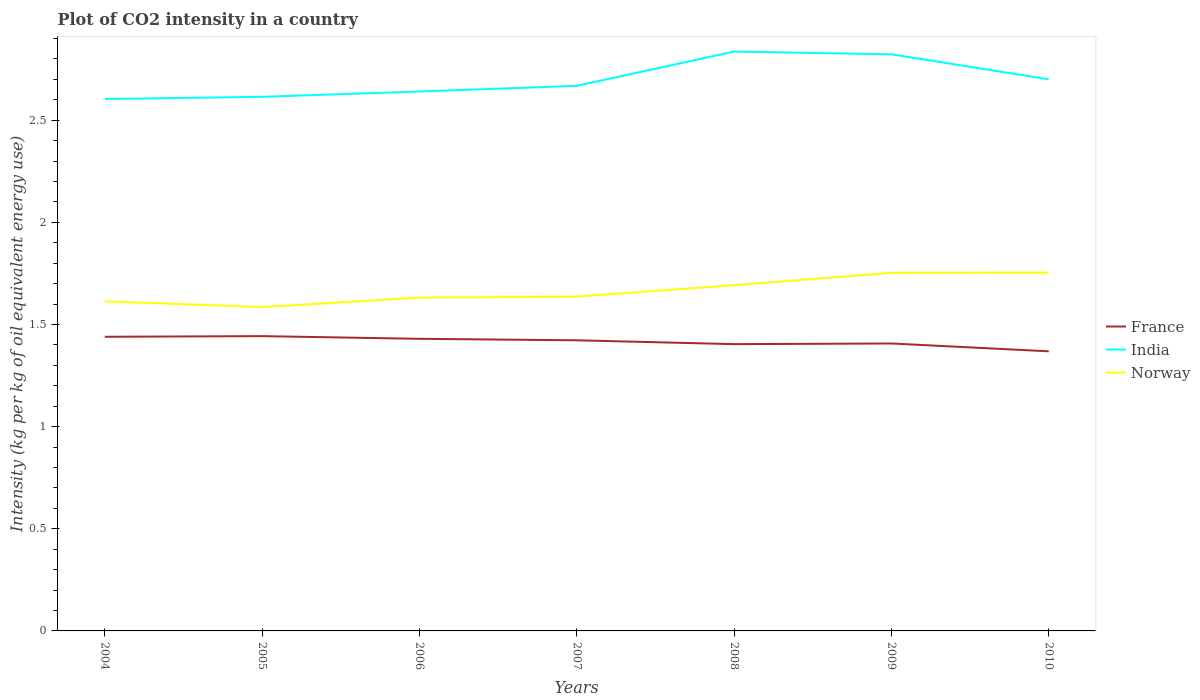How many different coloured lines are there?
Offer a terse response. 3. Does the line corresponding to India intersect with the line corresponding to Norway?
Provide a succinct answer. No. Is the number of lines equal to the number of legend labels?
Ensure brevity in your answer.  Yes. Across all years, what is the maximum CO2 intensity in in Norway?
Your response must be concise. 1.59. In which year was the CO2 intensity in in India maximum?
Make the answer very short. 2004. What is the total CO2 intensity in in Norway in the graph?
Keep it short and to the point. -0.14. What is the difference between the highest and the second highest CO2 intensity in in India?
Your response must be concise. 0.23. What is the difference between the highest and the lowest CO2 intensity in in Norway?
Your answer should be compact. 3. Is the CO2 intensity in in India strictly greater than the CO2 intensity in in France over the years?
Offer a very short reply. No. How many years are there in the graph?
Provide a succinct answer. 7. Are the values on the major ticks of Y-axis written in scientific E-notation?
Your response must be concise. No. Where does the legend appear in the graph?
Your response must be concise. Center right. How many legend labels are there?
Offer a very short reply. 3. How are the legend labels stacked?
Provide a short and direct response. Vertical. What is the title of the graph?
Provide a short and direct response. Plot of CO2 intensity in a country. What is the label or title of the Y-axis?
Your response must be concise. Intensity (kg per kg of oil equivalent energy use). What is the Intensity (kg per kg of oil equivalent energy use) of France in 2004?
Offer a terse response. 1.44. What is the Intensity (kg per kg of oil equivalent energy use) in India in 2004?
Give a very brief answer. 2.6. What is the Intensity (kg per kg of oil equivalent energy use) in Norway in 2004?
Make the answer very short. 1.61. What is the Intensity (kg per kg of oil equivalent energy use) in France in 2005?
Your answer should be very brief. 1.44. What is the Intensity (kg per kg of oil equivalent energy use) of India in 2005?
Ensure brevity in your answer.  2.61. What is the Intensity (kg per kg of oil equivalent energy use) in Norway in 2005?
Ensure brevity in your answer.  1.59. What is the Intensity (kg per kg of oil equivalent energy use) of France in 2006?
Your answer should be very brief. 1.43. What is the Intensity (kg per kg of oil equivalent energy use) of India in 2006?
Your answer should be compact. 2.64. What is the Intensity (kg per kg of oil equivalent energy use) of Norway in 2006?
Your answer should be very brief. 1.63. What is the Intensity (kg per kg of oil equivalent energy use) in France in 2007?
Your answer should be very brief. 1.42. What is the Intensity (kg per kg of oil equivalent energy use) of India in 2007?
Your response must be concise. 2.67. What is the Intensity (kg per kg of oil equivalent energy use) in Norway in 2007?
Provide a short and direct response. 1.64. What is the Intensity (kg per kg of oil equivalent energy use) of France in 2008?
Keep it short and to the point. 1.4. What is the Intensity (kg per kg of oil equivalent energy use) in India in 2008?
Your response must be concise. 2.84. What is the Intensity (kg per kg of oil equivalent energy use) in Norway in 2008?
Your answer should be very brief. 1.69. What is the Intensity (kg per kg of oil equivalent energy use) of France in 2009?
Provide a succinct answer. 1.41. What is the Intensity (kg per kg of oil equivalent energy use) in India in 2009?
Keep it short and to the point. 2.82. What is the Intensity (kg per kg of oil equivalent energy use) in Norway in 2009?
Offer a very short reply. 1.75. What is the Intensity (kg per kg of oil equivalent energy use) in France in 2010?
Offer a terse response. 1.37. What is the Intensity (kg per kg of oil equivalent energy use) of India in 2010?
Your answer should be very brief. 2.7. What is the Intensity (kg per kg of oil equivalent energy use) in Norway in 2010?
Your answer should be compact. 1.75. Across all years, what is the maximum Intensity (kg per kg of oil equivalent energy use) of France?
Give a very brief answer. 1.44. Across all years, what is the maximum Intensity (kg per kg of oil equivalent energy use) in India?
Provide a succinct answer. 2.84. Across all years, what is the maximum Intensity (kg per kg of oil equivalent energy use) in Norway?
Ensure brevity in your answer.  1.75. Across all years, what is the minimum Intensity (kg per kg of oil equivalent energy use) in France?
Offer a very short reply. 1.37. Across all years, what is the minimum Intensity (kg per kg of oil equivalent energy use) of India?
Keep it short and to the point. 2.6. Across all years, what is the minimum Intensity (kg per kg of oil equivalent energy use) of Norway?
Provide a succinct answer. 1.59. What is the total Intensity (kg per kg of oil equivalent energy use) of France in the graph?
Your response must be concise. 9.91. What is the total Intensity (kg per kg of oil equivalent energy use) in India in the graph?
Provide a succinct answer. 18.89. What is the total Intensity (kg per kg of oil equivalent energy use) in Norway in the graph?
Offer a terse response. 11.67. What is the difference between the Intensity (kg per kg of oil equivalent energy use) in France in 2004 and that in 2005?
Your answer should be very brief. -0. What is the difference between the Intensity (kg per kg of oil equivalent energy use) of India in 2004 and that in 2005?
Your answer should be compact. -0.01. What is the difference between the Intensity (kg per kg of oil equivalent energy use) of Norway in 2004 and that in 2005?
Offer a terse response. 0.03. What is the difference between the Intensity (kg per kg of oil equivalent energy use) in France in 2004 and that in 2006?
Your answer should be very brief. 0.01. What is the difference between the Intensity (kg per kg of oil equivalent energy use) in India in 2004 and that in 2006?
Provide a succinct answer. -0.04. What is the difference between the Intensity (kg per kg of oil equivalent energy use) in Norway in 2004 and that in 2006?
Offer a very short reply. -0.02. What is the difference between the Intensity (kg per kg of oil equivalent energy use) of France in 2004 and that in 2007?
Provide a short and direct response. 0.02. What is the difference between the Intensity (kg per kg of oil equivalent energy use) of India in 2004 and that in 2007?
Provide a short and direct response. -0.06. What is the difference between the Intensity (kg per kg of oil equivalent energy use) of Norway in 2004 and that in 2007?
Keep it short and to the point. -0.02. What is the difference between the Intensity (kg per kg of oil equivalent energy use) of France in 2004 and that in 2008?
Your response must be concise. 0.04. What is the difference between the Intensity (kg per kg of oil equivalent energy use) in India in 2004 and that in 2008?
Provide a short and direct response. -0.23. What is the difference between the Intensity (kg per kg of oil equivalent energy use) of Norway in 2004 and that in 2008?
Offer a terse response. -0.08. What is the difference between the Intensity (kg per kg of oil equivalent energy use) in France in 2004 and that in 2009?
Your response must be concise. 0.03. What is the difference between the Intensity (kg per kg of oil equivalent energy use) of India in 2004 and that in 2009?
Ensure brevity in your answer.  -0.22. What is the difference between the Intensity (kg per kg of oil equivalent energy use) of Norway in 2004 and that in 2009?
Make the answer very short. -0.14. What is the difference between the Intensity (kg per kg of oil equivalent energy use) in France in 2004 and that in 2010?
Ensure brevity in your answer.  0.07. What is the difference between the Intensity (kg per kg of oil equivalent energy use) in India in 2004 and that in 2010?
Offer a terse response. -0.1. What is the difference between the Intensity (kg per kg of oil equivalent energy use) of Norway in 2004 and that in 2010?
Keep it short and to the point. -0.14. What is the difference between the Intensity (kg per kg of oil equivalent energy use) in France in 2005 and that in 2006?
Give a very brief answer. 0.01. What is the difference between the Intensity (kg per kg of oil equivalent energy use) in India in 2005 and that in 2006?
Make the answer very short. -0.03. What is the difference between the Intensity (kg per kg of oil equivalent energy use) in Norway in 2005 and that in 2006?
Give a very brief answer. -0.05. What is the difference between the Intensity (kg per kg of oil equivalent energy use) in France in 2005 and that in 2007?
Keep it short and to the point. 0.02. What is the difference between the Intensity (kg per kg of oil equivalent energy use) in India in 2005 and that in 2007?
Offer a very short reply. -0.05. What is the difference between the Intensity (kg per kg of oil equivalent energy use) in Norway in 2005 and that in 2007?
Give a very brief answer. -0.05. What is the difference between the Intensity (kg per kg of oil equivalent energy use) in France in 2005 and that in 2008?
Your response must be concise. 0.04. What is the difference between the Intensity (kg per kg of oil equivalent energy use) of India in 2005 and that in 2008?
Your answer should be very brief. -0.22. What is the difference between the Intensity (kg per kg of oil equivalent energy use) of Norway in 2005 and that in 2008?
Provide a succinct answer. -0.11. What is the difference between the Intensity (kg per kg of oil equivalent energy use) in France in 2005 and that in 2009?
Your response must be concise. 0.04. What is the difference between the Intensity (kg per kg of oil equivalent energy use) in India in 2005 and that in 2009?
Make the answer very short. -0.21. What is the difference between the Intensity (kg per kg of oil equivalent energy use) of Norway in 2005 and that in 2009?
Provide a short and direct response. -0.17. What is the difference between the Intensity (kg per kg of oil equivalent energy use) in France in 2005 and that in 2010?
Provide a short and direct response. 0.07. What is the difference between the Intensity (kg per kg of oil equivalent energy use) of India in 2005 and that in 2010?
Your answer should be very brief. -0.09. What is the difference between the Intensity (kg per kg of oil equivalent energy use) of Norway in 2005 and that in 2010?
Offer a terse response. -0.17. What is the difference between the Intensity (kg per kg of oil equivalent energy use) of France in 2006 and that in 2007?
Provide a succinct answer. 0.01. What is the difference between the Intensity (kg per kg of oil equivalent energy use) of India in 2006 and that in 2007?
Keep it short and to the point. -0.03. What is the difference between the Intensity (kg per kg of oil equivalent energy use) in Norway in 2006 and that in 2007?
Make the answer very short. -0.01. What is the difference between the Intensity (kg per kg of oil equivalent energy use) of France in 2006 and that in 2008?
Provide a succinct answer. 0.03. What is the difference between the Intensity (kg per kg of oil equivalent energy use) in India in 2006 and that in 2008?
Give a very brief answer. -0.2. What is the difference between the Intensity (kg per kg of oil equivalent energy use) of Norway in 2006 and that in 2008?
Provide a short and direct response. -0.06. What is the difference between the Intensity (kg per kg of oil equivalent energy use) of France in 2006 and that in 2009?
Ensure brevity in your answer.  0.02. What is the difference between the Intensity (kg per kg of oil equivalent energy use) in India in 2006 and that in 2009?
Your response must be concise. -0.18. What is the difference between the Intensity (kg per kg of oil equivalent energy use) of Norway in 2006 and that in 2009?
Your response must be concise. -0.12. What is the difference between the Intensity (kg per kg of oil equivalent energy use) in France in 2006 and that in 2010?
Your answer should be very brief. 0.06. What is the difference between the Intensity (kg per kg of oil equivalent energy use) of India in 2006 and that in 2010?
Ensure brevity in your answer.  -0.06. What is the difference between the Intensity (kg per kg of oil equivalent energy use) of Norway in 2006 and that in 2010?
Your answer should be compact. -0.12. What is the difference between the Intensity (kg per kg of oil equivalent energy use) of France in 2007 and that in 2008?
Keep it short and to the point. 0.02. What is the difference between the Intensity (kg per kg of oil equivalent energy use) of India in 2007 and that in 2008?
Your answer should be compact. -0.17. What is the difference between the Intensity (kg per kg of oil equivalent energy use) in Norway in 2007 and that in 2008?
Provide a short and direct response. -0.06. What is the difference between the Intensity (kg per kg of oil equivalent energy use) of France in 2007 and that in 2009?
Your answer should be compact. 0.02. What is the difference between the Intensity (kg per kg of oil equivalent energy use) of India in 2007 and that in 2009?
Offer a very short reply. -0.15. What is the difference between the Intensity (kg per kg of oil equivalent energy use) in Norway in 2007 and that in 2009?
Offer a terse response. -0.12. What is the difference between the Intensity (kg per kg of oil equivalent energy use) in France in 2007 and that in 2010?
Provide a short and direct response. 0.05. What is the difference between the Intensity (kg per kg of oil equivalent energy use) of India in 2007 and that in 2010?
Keep it short and to the point. -0.03. What is the difference between the Intensity (kg per kg of oil equivalent energy use) of Norway in 2007 and that in 2010?
Your response must be concise. -0.12. What is the difference between the Intensity (kg per kg of oil equivalent energy use) of France in 2008 and that in 2009?
Ensure brevity in your answer.  -0. What is the difference between the Intensity (kg per kg of oil equivalent energy use) of India in 2008 and that in 2009?
Make the answer very short. 0.01. What is the difference between the Intensity (kg per kg of oil equivalent energy use) of Norway in 2008 and that in 2009?
Make the answer very short. -0.06. What is the difference between the Intensity (kg per kg of oil equivalent energy use) in France in 2008 and that in 2010?
Offer a terse response. 0.04. What is the difference between the Intensity (kg per kg of oil equivalent energy use) in India in 2008 and that in 2010?
Your answer should be compact. 0.14. What is the difference between the Intensity (kg per kg of oil equivalent energy use) in Norway in 2008 and that in 2010?
Offer a terse response. -0.06. What is the difference between the Intensity (kg per kg of oil equivalent energy use) of France in 2009 and that in 2010?
Your answer should be very brief. 0.04. What is the difference between the Intensity (kg per kg of oil equivalent energy use) of India in 2009 and that in 2010?
Your answer should be very brief. 0.12. What is the difference between the Intensity (kg per kg of oil equivalent energy use) in Norway in 2009 and that in 2010?
Your response must be concise. -0. What is the difference between the Intensity (kg per kg of oil equivalent energy use) of France in 2004 and the Intensity (kg per kg of oil equivalent energy use) of India in 2005?
Keep it short and to the point. -1.17. What is the difference between the Intensity (kg per kg of oil equivalent energy use) in France in 2004 and the Intensity (kg per kg of oil equivalent energy use) in Norway in 2005?
Provide a short and direct response. -0.15. What is the difference between the Intensity (kg per kg of oil equivalent energy use) in India in 2004 and the Intensity (kg per kg of oil equivalent energy use) in Norway in 2005?
Ensure brevity in your answer.  1.02. What is the difference between the Intensity (kg per kg of oil equivalent energy use) of France in 2004 and the Intensity (kg per kg of oil equivalent energy use) of India in 2006?
Give a very brief answer. -1.2. What is the difference between the Intensity (kg per kg of oil equivalent energy use) in France in 2004 and the Intensity (kg per kg of oil equivalent energy use) in Norway in 2006?
Provide a short and direct response. -0.19. What is the difference between the Intensity (kg per kg of oil equivalent energy use) of India in 2004 and the Intensity (kg per kg of oil equivalent energy use) of Norway in 2006?
Offer a very short reply. 0.97. What is the difference between the Intensity (kg per kg of oil equivalent energy use) in France in 2004 and the Intensity (kg per kg of oil equivalent energy use) in India in 2007?
Your answer should be compact. -1.23. What is the difference between the Intensity (kg per kg of oil equivalent energy use) of France in 2004 and the Intensity (kg per kg of oil equivalent energy use) of Norway in 2007?
Give a very brief answer. -0.2. What is the difference between the Intensity (kg per kg of oil equivalent energy use) in India in 2004 and the Intensity (kg per kg of oil equivalent energy use) in Norway in 2007?
Your answer should be compact. 0.97. What is the difference between the Intensity (kg per kg of oil equivalent energy use) in France in 2004 and the Intensity (kg per kg of oil equivalent energy use) in India in 2008?
Provide a short and direct response. -1.4. What is the difference between the Intensity (kg per kg of oil equivalent energy use) in France in 2004 and the Intensity (kg per kg of oil equivalent energy use) in Norway in 2008?
Provide a succinct answer. -0.25. What is the difference between the Intensity (kg per kg of oil equivalent energy use) of India in 2004 and the Intensity (kg per kg of oil equivalent energy use) of Norway in 2008?
Keep it short and to the point. 0.91. What is the difference between the Intensity (kg per kg of oil equivalent energy use) of France in 2004 and the Intensity (kg per kg of oil equivalent energy use) of India in 2009?
Offer a very short reply. -1.38. What is the difference between the Intensity (kg per kg of oil equivalent energy use) of France in 2004 and the Intensity (kg per kg of oil equivalent energy use) of Norway in 2009?
Give a very brief answer. -0.31. What is the difference between the Intensity (kg per kg of oil equivalent energy use) of India in 2004 and the Intensity (kg per kg of oil equivalent energy use) of Norway in 2009?
Offer a terse response. 0.85. What is the difference between the Intensity (kg per kg of oil equivalent energy use) of France in 2004 and the Intensity (kg per kg of oil equivalent energy use) of India in 2010?
Keep it short and to the point. -1.26. What is the difference between the Intensity (kg per kg of oil equivalent energy use) in France in 2004 and the Intensity (kg per kg of oil equivalent energy use) in Norway in 2010?
Make the answer very short. -0.31. What is the difference between the Intensity (kg per kg of oil equivalent energy use) in India in 2004 and the Intensity (kg per kg of oil equivalent energy use) in Norway in 2010?
Your answer should be compact. 0.85. What is the difference between the Intensity (kg per kg of oil equivalent energy use) of France in 2005 and the Intensity (kg per kg of oil equivalent energy use) of India in 2006?
Keep it short and to the point. -1.2. What is the difference between the Intensity (kg per kg of oil equivalent energy use) of France in 2005 and the Intensity (kg per kg of oil equivalent energy use) of Norway in 2006?
Give a very brief answer. -0.19. What is the difference between the Intensity (kg per kg of oil equivalent energy use) of India in 2005 and the Intensity (kg per kg of oil equivalent energy use) of Norway in 2006?
Offer a very short reply. 0.98. What is the difference between the Intensity (kg per kg of oil equivalent energy use) in France in 2005 and the Intensity (kg per kg of oil equivalent energy use) in India in 2007?
Your answer should be compact. -1.23. What is the difference between the Intensity (kg per kg of oil equivalent energy use) of France in 2005 and the Intensity (kg per kg of oil equivalent energy use) of Norway in 2007?
Give a very brief answer. -0.19. What is the difference between the Intensity (kg per kg of oil equivalent energy use) in India in 2005 and the Intensity (kg per kg of oil equivalent energy use) in Norway in 2007?
Offer a terse response. 0.98. What is the difference between the Intensity (kg per kg of oil equivalent energy use) of France in 2005 and the Intensity (kg per kg of oil equivalent energy use) of India in 2008?
Keep it short and to the point. -1.39. What is the difference between the Intensity (kg per kg of oil equivalent energy use) of France in 2005 and the Intensity (kg per kg of oil equivalent energy use) of Norway in 2008?
Provide a succinct answer. -0.25. What is the difference between the Intensity (kg per kg of oil equivalent energy use) in India in 2005 and the Intensity (kg per kg of oil equivalent energy use) in Norway in 2008?
Provide a succinct answer. 0.92. What is the difference between the Intensity (kg per kg of oil equivalent energy use) in France in 2005 and the Intensity (kg per kg of oil equivalent energy use) in India in 2009?
Your answer should be very brief. -1.38. What is the difference between the Intensity (kg per kg of oil equivalent energy use) of France in 2005 and the Intensity (kg per kg of oil equivalent energy use) of Norway in 2009?
Provide a short and direct response. -0.31. What is the difference between the Intensity (kg per kg of oil equivalent energy use) in India in 2005 and the Intensity (kg per kg of oil equivalent energy use) in Norway in 2009?
Your response must be concise. 0.86. What is the difference between the Intensity (kg per kg of oil equivalent energy use) of France in 2005 and the Intensity (kg per kg of oil equivalent energy use) of India in 2010?
Provide a succinct answer. -1.26. What is the difference between the Intensity (kg per kg of oil equivalent energy use) in France in 2005 and the Intensity (kg per kg of oil equivalent energy use) in Norway in 2010?
Offer a very short reply. -0.31. What is the difference between the Intensity (kg per kg of oil equivalent energy use) of India in 2005 and the Intensity (kg per kg of oil equivalent energy use) of Norway in 2010?
Offer a terse response. 0.86. What is the difference between the Intensity (kg per kg of oil equivalent energy use) of France in 2006 and the Intensity (kg per kg of oil equivalent energy use) of India in 2007?
Provide a short and direct response. -1.24. What is the difference between the Intensity (kg per kg of oil equivalent energy use) in France in 2006 and the Intensity (kg per kg of oil equivalent energy use) in Norway in 2007?
Make the answer very short. -0.21. What is the difference between the Intensity (kg per kg of oil equivalent energy use) in France in 2006 and the Intensity (kg per kg of oil equivalent energy use) in India in 2008?
Give a very brief answer. -1.41. What is the difference between the Intensity (kg per kg of oil equivalent energy use) in France in 2006 and the Intensity (kg per kg of oil equivalent energy use) in Norway in 2008?
Ensure brevity in your answer.  -0.26. What is the difference between the Intensity (kg per kg of oil equivalent energy use) in India in 2006 and the Intensity (kg per kg of oil equivalent energy use) in Norway in 2008?
Your response must be concise. 0.95. What is the difference between the Intensity (kg per kg of oil equivalent energy use) of France in 2006 and the Intensity (kg per kg of oil equivalent energy use) of India in 2009?
Your response must be concise. -1.39. What is the difference between the Intensity (kg per kg of oil equivalent energy use) in France in 2006 and the Intensity (kg per kg of oil equivalent energy use) in Norway in 2009?
Provide a short and direct response. -0.32. What is the difference between the Intensity (kg per kg of oil equivalent energy use) in India in 2006 and the Intensity (kg per kg of oil equivalent energy use) in Norway in 2009?
Your response must be concise. 0.89. What is the difference between the Intensity (kg per kg of oil equivalent energy use) of France in 2006 and the Intensity (kg per kg of oil equivalent energy use) of India in 2010?
Offer a very short reply. -1.27. What is the difference between the Intensity (kg per kg of oil equivalent energy use) of France in 2006 and the Intensity (kg per kg of oil equivalent energy use) of Norway in 2010?
Offer a very short reply. -0.32. What is the difference between the Intensity (kg per kg of oil equivalent energy use) in India in 2006 and the Intensity (kg per kg of oil equivalent energy use) in Norway in 2010?
Offer a terse response. 0.89. What is the difference between the Intensity (kg per kg of oil equivalent energy use) of France in 2007 and the Intensity (kg per kg of oil equivalent energy use) of India in 2008?
Your answer should be compact. -1.41. What is the difference between the Intensity (kg per kg of oil equivalent energy use) of France in 2007 and the Intensity (kg per kg of oil equivalent energy use) of Norway in 2008?
Your response must be concise. -0.27. What is the difference between the Intensity (kg per kg of oil equivalent energy use) of India in 2007 and the Intensity (kg per kg of oil equivalent energy use) of Norway in 2008?
Offer a very short reply. 0.98. What is the difference between the Intensity (kg per kg of oil equivalent energy use) in France in 2007 and the Intensity (kg per kg of oil equivalent energy use) in India in 2009?
Give a very brief answer. -1.4. What is the difference between the Intensity (kg per kg of oil equivalent energy use) of France in 2007 and the Intensity (kg per kg of oil equivalent energy use) of Norway in 2009?
Your answer should be very brief. -0.33. What is the difference between the Intensity (kg per kg of oil equivalent energy use) in India in 2007 and the Intensity (kg per kg of oil equivalent energy use) in Norway in 2009?
Keep it short and to the point. 0.92. What is the difference between the Intensity (kg per kg of oil equivalent energy use) of France in 2007 and the Intensity (kg per kg of oil equivalent energy use) of India in 2010?
Give a very brief answer. -1.28. What is the difference between the Intensity (kg per kg of oil equivalent energy use) in France in 2007 and the Intensity (kg per kg of oil equivalent energy use) in Norway in 2010?
Your answer should be compact. -0.33. What is the difference between the Intensity (kg per kg of oil equivalent energy use) in India in 2007 and the Intensity (kg per kg of oil equivalent energy use) in Norway in 2010?
Make the answer very short. 0.91. What is the difference between the Intensity (kg per kg of oil equivalent energy use) in France in 2008 and the Intensity (kg per kg of oil equivalent energy use) in India in 2009?
Offer a very short reply. -1.42. What is the difference between the Intensity (kg per kg of oil equivalent energy use) in France in 2008 and the Intensity (kg per kg of oil equivalent energy use) in Norway in 2009?
Ensure brevity in your answer.  -0.35. What is the difference between the Intensity (kg per kg of oil equivalent energy use) of India in 2008 and the Intensity (kg per kg of oil equivalent energy use) of Norway in 2009?
Provide a short and direct response. 1.08. What is the difference between the Intensity (kg per kg of oil equivalent energy use) in France in 2008 and the Intensity (kg per kg of oil equivalent energy use) in India in 2010?
Provide a short and direct response. -1.3. What is the difference between the Intensity (kg per kg of oil equivalent energy use) of France in 2008 and the Intensity (kg per kg of oil equivalent energy use) of Norway in 2010?
Provide a short and direct response. -0.35. What is the difference between the Intensity (kg per kg of oil equivalent energy use) of India in 2008 and the Intensity (kg per kg of oil equivalent energy use) of Norway in 2010?
Your response must be concise. 1.08. What is the difference between the Intensity (kg per kg of oil equivalent energy use) in France in 2009 and the Intensity (kg per kg of oil equivalent energy use) in India in 2010?
Give a very brief answer. -1.29. What is the difference between the Intensity (kg per kg of oil equivalent energy use) in France in 2009 and the Intensity (kg per kg of oil equivalent energy use) in Norway in 2010?
Offer a terse response. -0.35. What is the difference between the Intensity (kg per kg of oil equivalent energy use) in India in 2009 and the Intensity (kg per kg of oil equivalent energy use) in Norway in 2010?
Your response must be concise. 1.07. What is the average Intensity (kg per kg of oil equivalent energy use) in France per year?
Provide a short and direct response. 1.42. What is the average Intensity (kg per kg of oil equivalent energy use) of India per year?
Your answer should be very brief. 2.7. What is the average Intensity (kg per kg of oil equivalent energy use) in Norway per year?
Provide a short and direct response. 1.67. In the year 2004, what is the difference between the Intensity (kg per kg of oil equivalent energy use) in France and Intensity (kg per kg of oil equivalent energy use) in India?
Keep it short and to the point. -1.16. In the year 2004, what is the difference between the Intensity (kg per kg of oil equivalent energy use) in France and Intensity (kg per kg of oil equivalent energy use) in Norway?
Offer a terse response. -0.17. In the year 2004, what is the difference between the Intensity (kg per kg of oil equivalent energy use) of India and Intensity (kg per kg of oil equivalent energy use) of Norway?
Your response must be concise. 0.99. In the year 2005, what is the difference between the Intensity (kg per kg of oil equivalent energy use) of France and Intensity (kg per kg of oil equivalent energy use) of India?
Your answer should be very brief. -1.17. In the year 2005, what is the difference between the Intensity (kg per kg of oil equivalent energy use) in France and Intensity (kg per kg of oil equivalent energy use) in Norway?
Your answer should be compact. -0.14. In the year 2005, what is the difference between the Intensity (kg per kg of oil equivalent energy use) in India and Intensity (kg per kg of oil equivalent energy use) in Norway?
Your response must be concise. 1.03. In the year 2006, what is the difference between the Intensity (kg per kg of oil equivalent energy use) in France and Intensity (kg per kg of oil equivalent energy use) in India?
Keep it short and to the point. -1.21. In the year 2006, what is the difference between the Intensity (kg per kg of oil equivalent energy use) of France and Intensity (kg per kg of oil equivalent energy use) of Norway?
Ensure brevity in your answer.  -0.2. In the year 2006, what is the difference between the Intensity (kg per kg of oil equivalent energy use) in India and Intensity (kg per kg of oil equivalent energy use) in Norway?
Ensure brevity in your answer.  1.01. In the year 2007, what is the difference between the Intensity (kg per kg of oil equivalent energy use) of France and Intensity (kg per kg of oil equivalent energy use) of India?
Make the answer very short. -1.25. In the year 2007, what is the difference between the Intensity (kg per kg of oil equivalent energy use) in France and Intensity (kg per kg of oil equivalent energy use) in Norway?
Make the answer very short. -0.21. In the year 2007, what is the difference between the Intensity (kg per kg of oil equivalent energy use) of India and Intensity (kg per kg of oil equivalent energy use) of Norway?
Your answer should be compact. 1.03. In the year 2008, what is the difference between the Intensity (kg per kg of oil equivalent energy use) of France and Intensity (kg per kg of oil equivalent energy use) of India?
Your response must be concise. -1.43. In the year 2008, what is the difference between the Intensity (kg per kg of oil equivalent energy use) in France and Intensity (kg per kg of oil equivalent energy use) in Norway?
Offer a very short reply. -0.29. In the year 2008, what is the difference between the Intensity (kg per kg of oil equivalent energy use) in India and Intensity (kg per kg of oil equivalent energy use) in Norway?
Your answer should be very brief. 1.14. In the year 2009, what is the difference between the Intensity (kg per kg of oil equivalent energy use) in France and Intensity (kg per kg of oil equivalent energy use) in India?
Offer a terse response. -1.42. In the year 2009, what is the difference between the Intensity (kg per kg of oil equivalent energy use) in France and Intensity (kg per kg of oil equivalent energy use) in Norway?
Your response must be concise. -0.35. In the year 2009, what is the difference between the Intensity (kg per kg of oil equivalent energy use) of India and Intensity (kg per kg of oil equivalent energy use) of Norway?
Your response must be concise. 1.07. In the year 2010, what is the difference between the Intensity (kg per kg of oil equivalent energy use) of France and Intensity (kg per kg of oil equivalent energy use) of India?
Provide a short and direct response. -1.33. In the year 2010, what is the difference between the Intensity (kg per kg of oil equivalent energy use) in France and Intensity (kg per kg of oil equivalent energy use) in Norway?
Offer a terse response. -0.39. In the year 2010, what is the difference between the Intensity (kg per kg of oil equivalent energy use) in India and Intensity (kg per kg of oil equivalent energy use) in Norway?
Give a very brief answer. 0.95. What is the ratio of the Intensity (kg per kg of oil equivalent energy use) in France in 2004 to that in 2005?
Your response must be concise. 1. What is the ratio of the Intensity (kg per kg of oil equivalent energy use) of Norway in 2004 to that in 2005?
Your response must be concise. 1.02. What is the ratio of the Intensity (kg per kg of oil equivalent energy use) of India in 2004 to that in 2006?
Offer a very short reply. 0.99. What is the ratio of the Intensity (kg per kg of oil equivalent energy use) in Norway in 2004 to that in 2006?
Provide a short and direct response. 0.99. What is the ratio of the Intensity (kg per kg of oil equivalent energy use) of France in 2004 to that in 2007?
Your answer should be very brief. 1.01. What is the ratio of the Intensity (kg per kg of oil equivalent energy use) in India in 2004 to that in 2007?
Your answer should be compact. 0.98. What is the ratio of the Intensity (kg per kg of oil equivalent energy use) in Norway in 2004 to that in 2007?
Your answer should be compact. 0.99. What is the ratio of the Intensity (kg per kg of oil equivalent energy use) of France in 2004 to that in 2008?
Ensure brevity in your answer.  1.03. What is the ratio of the Intensity (kg per kg of oil equivalent energy use) in India in 2004 to that in 2008?
Your answer should be very brief. 0.92. What is the ratio of the Intensity (kg per kg of oil equivalent energy use) of Norway in 2004 to that in 2008?
Your answer should be very brief. 0.95. What is the ratio of the Intensity (kg per kg of oil equivalent energy use) of France in 2004 to that in 2009?
Offer a very short reply. 1.02. What is the ratio of the Intensity (kg per kg of oil equivalent energy use) of India in 2004 to that in 2009?
Offer a very short reply. 0.92. What is the ratio of the Intensity (kg per kg of oil equivalent energy use) of Norway in 2004 to that in 2009?
Give a very brief answer. 0.92. What is the ratio of the Intensity (kg per kg of oil equivalent energy use) of France in 2004 to that in 2010?
Your answer should be very brief. 1.05. What is the ratio of the Intensity (kg per kg of oil equivalent energy use) of India in 2004 to that in 2010?
Offer a very short reply. 0.96. What is the ratio of the Intensity (kg per kg of oil equivalent energy use) of Norway in 2004 to that in 2010?
Offer a terse response. 0.92. What is the ratio of the Intensity (kg per kg of oil equivalent energy use) of France in 2005 to that in 2006?
Give a very brief answer. 1.01. What is the ratio of the Intensity (kg per kg of oil equivalent energy use) in India in 2005 to that in 2006?
Your answer should be very brief. 0.99. What is the ratio of the Intensity (kg per kg of oil equivalent energy use) in Norway in 2005 to that in 2006?
Provide a succinct answer. 0.97. What is the ratio of the Intensity (kg per kg of oil equivalent energy use) in France in 2005 to that in 2007?
Offer a very short reply. 1.01. What is the ratio of the Intensity (kg per kg of oil equivalent energy use) of India in 2005 to that in 2007?
Your answer should be compact. 0.98. What is the ratio of the Intensity (kg per kg of oil equivalent energy use) of Norway in 2005 to that in 2007?
Your response must be concise. 0.97. What is the ratio of the Intensity (kg per kg of oil equivalent energy use) in France in 2005 to that in 2008?
Your answer should be compact. 1.03. What is the ratio of the Intensity (kg per kg of oil equivalent energy use) of India in 2005 to that in 2008?
Your response must be concise. 0.92. What is the ratio of the Intensity (kg per kg of oil equivalent energy use) in Norway in 2005 to that in 2008?
Provide a succinct answer. 0.94. What is the ratio of the Intensity (kg per kg of oil equivalent energy use) of France in 2005 to that in 2009?
Offer a terse response. 1.03. What is the ratio of the Intensity (kg per kg of oil equivalent energy use) of India in 2005 to that in 2009?
Keep it short and to the point. 0.93. What is the ratio of the Intensity (kg per kg of oil equivalent energy use) of Norway in 2005 to that in 2009?
Your answer should be compact. 0.9. What is the ratio of the Intensity (kg per kg of oil equivalent energy use) of France in 2005 to that in 2010?
Offer a very short reply. 1.05. What is the ratio of the Intensity (kg per kg of oil equivalent energy use) of India in 2005 to that in 2010?
Your answer should be very brief. 0.97. What is the ratio of the Intensity (kg per kg of oil equivalent energy use) in Norway in 2005 to that in 2010?
Provide a short and direct response. 0.9. What is the ratio of the Intensity (kg per kg of oil equivalent energy use) of Norway in 2006 to that in 2007?
Keep it short and to the point. 1. What is the ratio of the Intensity (kg per kg of oil equivalent energy use) of France in 2006 to that in 2008?
Offer a very short reply. 1.02. What is the ratio of the Intensity (kg per kg of oil equivalent energy use) of India in 2006 to that in 2008?
Keep it short and to the point. 0.93. What is the ratio of the Intensity (kg per kg of oil equivalent energy use) in Norway in 2006 to that in 2008?
Ensure brevity in your answer.  0.96. What is the ratio of the Intensity (kg per kg of oil equivalent energy use) in France in 2006 to that in 2009?
Your answer should be compact. 1.02. What is the ratio of the Intensity (kg per kg of oil equivalent energy use) in India in 2006 to that in 2009?
Make the answer very short. 0.94. What is the ratio of the Intensity (kg per kg of oil equivalent energy use) in Norway in 2006 to that in 2009?
Your response must be concise. 0.93. What is the ratio of the Intensity (kg per kg of oil equivalent energy use) of France in 2006 to that in 2010?
Offer a terse response. 1.04. What is the ratio of the Intensity (kg per kg of oil equivalent energy use) in India in 2006 to that in 2010?
Give a very brief answer. 0.98. What is the ratio of the Intensity (kg per kg of oil equivalent energy use) in Norway in 2006 to that in 2010?
Keep it short and to the point. 0.93. What is the ratio of the Intensity (kg per kg of oil equivalent energy use) in France in 2007 to that in 2008?
Provide a succinct answer. 1.01. What is the ratio of the Intensity (kg per kg of oil equivalent energy use) of India in 2007 to that in 2008?
Offer a very short reply. 0.94. What is the ratio of the Intensity (kg per kg of oil equivalent energy use) in Norway in 2007 to that in 2008?
Your answer should be compact. 0.97. What is the ratio of the Intensity (kg per kg of oil equivalent energy use) of India in 2007 to that in 2009?
Offer a terse response. 0.95. What is the ratio of the Intensity (kg per kg of oil equivalent energy use) in Norway in 2007 to that in 2009?
Your answer should be compact. 0.93. What is the ratio of the Intensity (kg per kg of oil equivalent energy use) of France in 2007 to that in 2010?
Offer a terse response. 1.04. What is the ratio of the Intensity (kg per kg of oil equivalent energy use) of Norway in 2007 to that in 2010?
Provide a short and direct response. 0.93. What is the ratio of the Intensity (kg per kg of oil equivalent energy use) in France in 2008 to that in 2009?
Ensure brevity in your answer.  1. What is the ratio of the Intensity (kg per kg of oil equivalent energy use) of India in 2008 to that in 2009?
Keep it short and to the point. 1. What is the ratio of the Intensity (kg per kg of oil equivalent energy use) in Norway in 2008 to that in 2009?
Give a very brief answer. 0.97. What is the ratio of the Intensity (kg per kg of oil equivalent energy use) of France in 2008 to that in 2010?
Your answer should be very brief. 1.03. What is the ratio of the Intensity (kg per kg of oil equivalent energy use) in India in 2008 to that in 2010?
Offer a terse response. 1.05. What is the ratio of the Intensity (kg per kg of oil equivalent energy use) in Norway in 2008 to that in 2010?
Keep it short and to the point. 0.96. What is the ratio of the Intensity (kg per kg of oil equivalent energy use) of France in 2009 to that in 2010?
Provide a short and direct response. 1.03. What is the ratio of the Intensity (kg per kg of oil equivalent energy use) in India in 2009 to that in 2010?
Offer a very short reply. 1.05. What is the difference between the highest and the second highest Intensity (kg per kg of oil equivalent energy use) in France?
Offer a very short reply. 0. What is the difference between the highest and the second highest Intensity (kg per kg of oil equivalent energy use) of India?
Provide a succinct answer. 0.01. What is the difference between the highest and the second highest Intensity (kg per kg of oil equivalent energy use) in Norway?
Your answer should be compact. 0. What is the difference between the highest and the lowest Intensity (kg per kg of oil equivalent energy use) in France?
Keep it short and to the point. 0.07. What is the difference between the highest and the lowest Intensity (kg per kg of oil equivalent energy use) of India?
Provide a short and direct response. 0.23. What is the difference between the highest and the lowest Intensity (kg per kg of oil equivalent energy use) of Norway?
Your response must be concise. 0.17. 